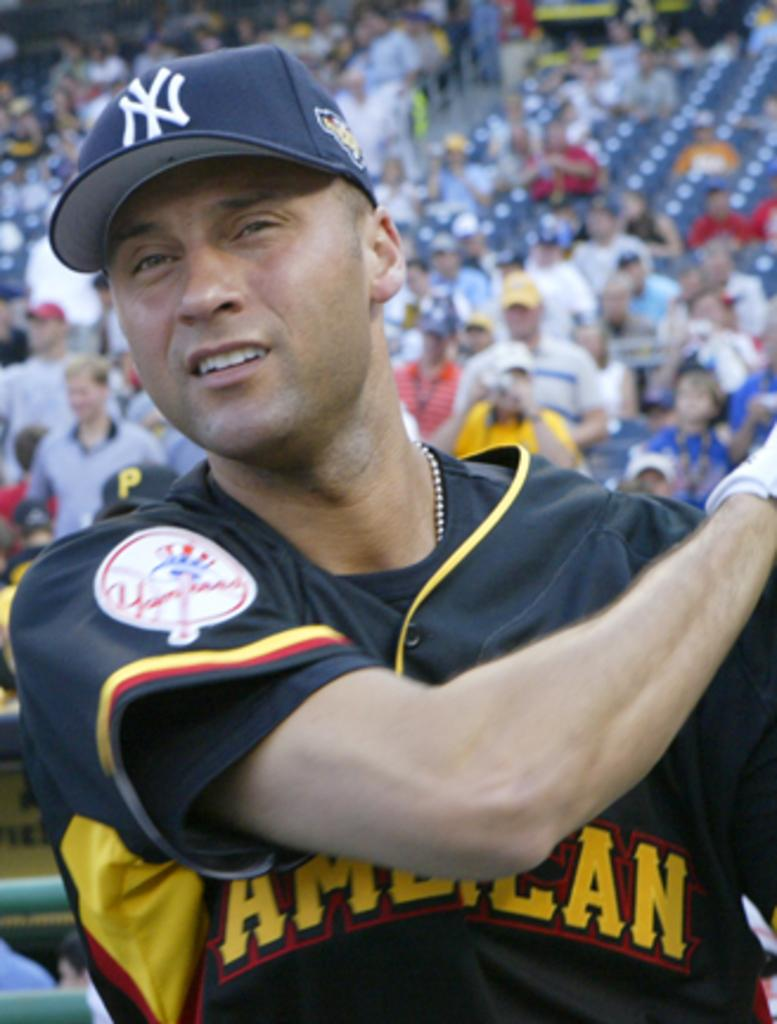Provide a one-sentence caption for the provided image. Yankee baseball player Derek Jeter is up to bat, he is wearing a blue uniform with white NY on cap and yellow wording on shirt spelling out: AMERICAN. 